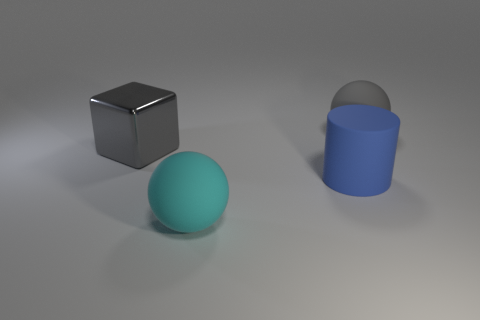The other big object that is the same color as the shiny thing is what shape? sphere 